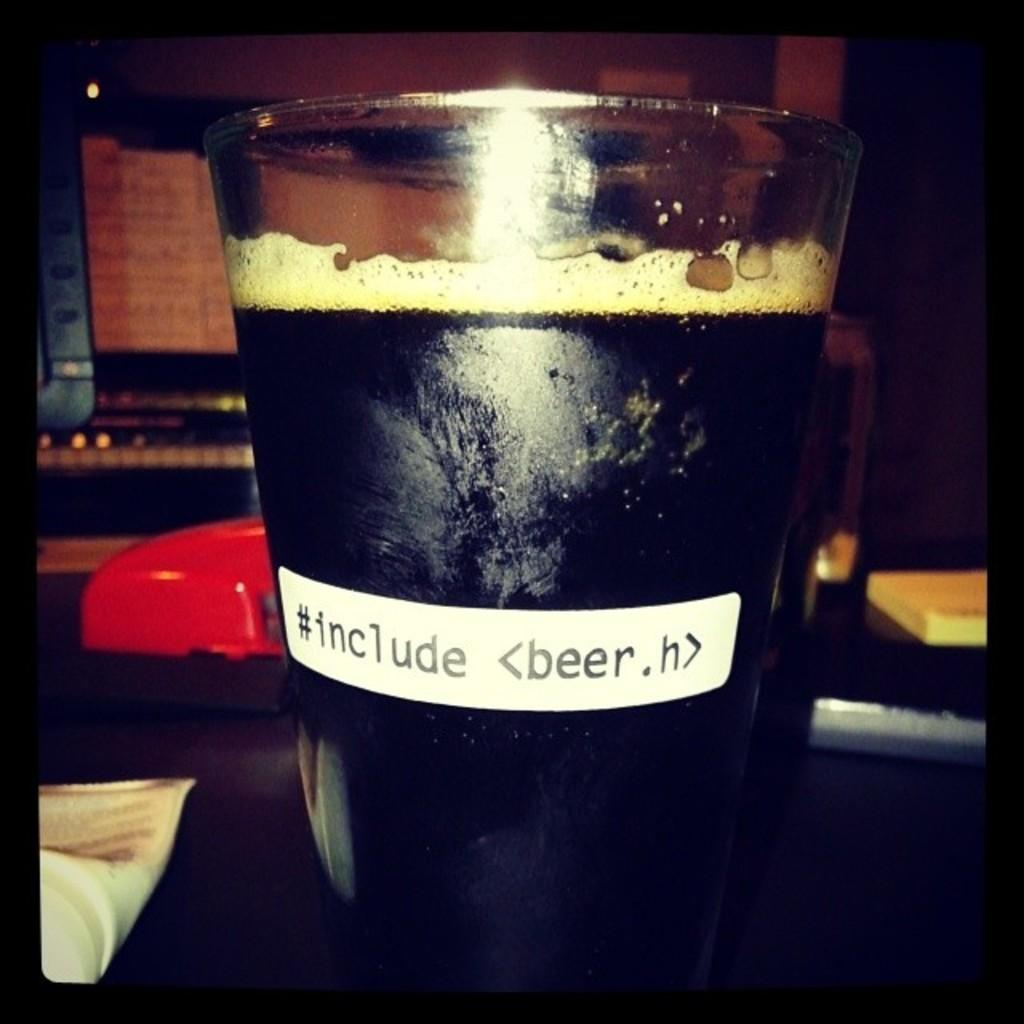<image>
Summarize the visual content of the image. A glass of dark beer with writing of #include <beer.h> 